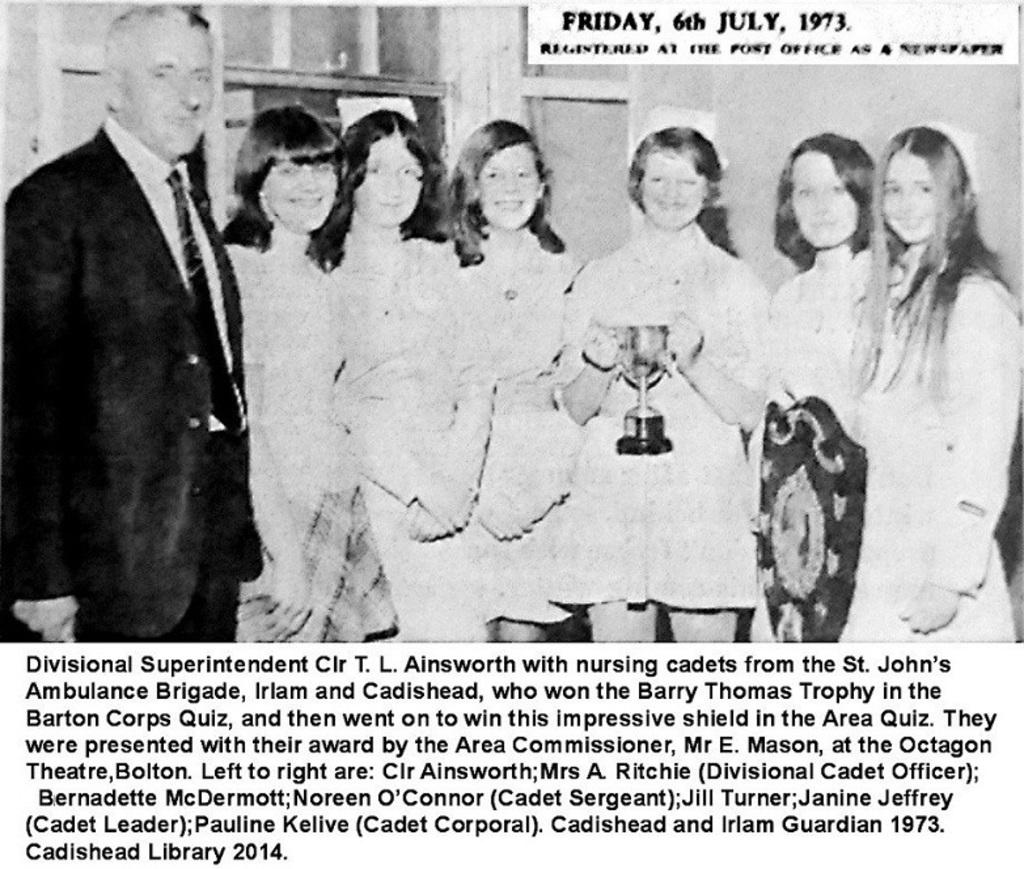What are the persons in the image doing? The persons in the image are posing for a camera. Can you describe the activity of the persons in the image? The persons are standing and posing for a camera, which suggests they are taking a group photo or participating in a photoshoot. What is written or displayed at the bottom of the image? There is text at the bottom of the image. What type of ring can be seen on the finger of the person in the image? There is no ring visible on any person's finger in the image. What color is the chalk used by the person in the image? There is no chalk present in the image; the persons are posing for a camera, not drawing or writing. 